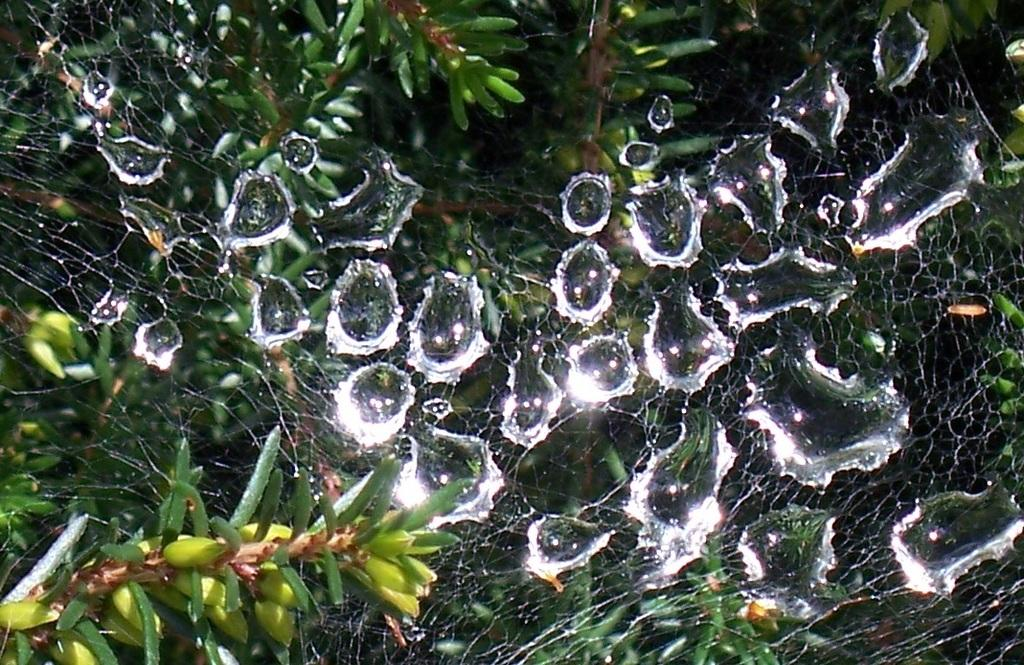What is present in the image between the plants? There is a spider web in the image between the plants. What is the condition of the spider web? The spider web has water droplets on it. What type of operation is being performed on the spider's knee in the image? There is no spider or knee present in the image, as it only features a spider web with water droplets between plants. 